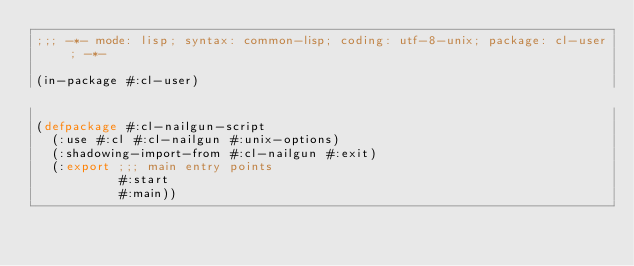<code> <loc_0><loc_0><loc_500><loc_500><_Lisp_>;;; -*- mode: lisp; syntax: common-lisp; coding: utf-8-unix; package: cl-user; -*-

(in-package #:cl-user)

(defpackage #:cl-nailgun-script
  (:use #:cl #:cl-nailgun #:unix-options)
  (:shadowing-import-from #:cl-nailgun #:exit)
  (:export ;;; main entry points
           #:start
           #:main))
</code> 